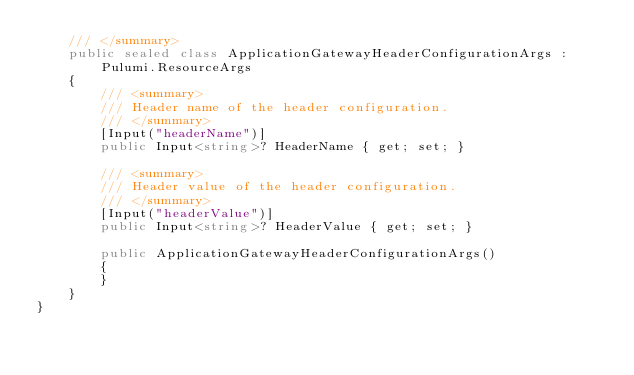<code> <loc_0><loc_0><loc_500><loc_500><_C#_>    /// </summary>
    public sealed class ApplicationGatewayHeaderConfigurationArgs : Pulumi.ResourceArgs
    {
        /// <summary>
        /// Header name of the header configuration.
        /// </summary>
        [Input("headerName")]
        public Input<string>? HeaderName { get; set; }

        /// <summary>
        /// Header value of the header configuration.
        /// </summary>
        [Input("headerValue")]
        public Input<string>? HeaderValue { get; set; }

        public ApplicationGatewayHeaderConfigurationArgs()
        {
        }
    }
}
</code> 